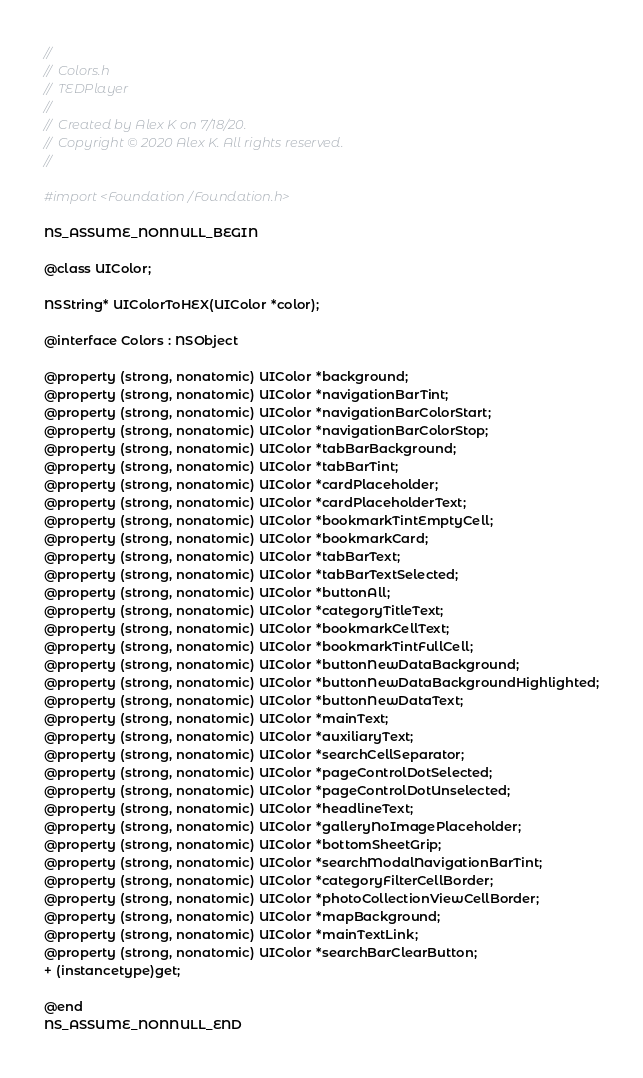Convert code to text. <code><loc_0><loc_0><loc_500><loc_500><_C_>//
//  Colors.h
//  TEDPlayer
//
//  Created by Alex K on 7/18/20.
//  Copyright © 2020 Alex K. All rights reserved.
//

#import <Foundation/Foundation.h>

NS_ASSUME_NONNULL_BEGIN

@class UIColor;

NSString* UIColorToHEX(UIColor *color);

@interface Colors : NSObject

@property (strong, nonatomic) UIColor *background;
@property (strong, nonatomic) UIColor *navigationBarTint;
@property (strong, nonatomic) UIColor *navigationBarColorStart;
@property (strong, nonatomic) UIColor *navigationBarColorStop;
@property (strong, nonatomic) UIColor *tabBarBackground;
@property (strong, nonatomic) UIColor *tabBarTint;
@property (strong, nonatomic) UIColor *cardPlaceholder;
@property (strong, nonatomic) UIColor *cardPlaceholderText;
@property (strong, nonatomic) UIColor *bookmarkTintEmptyCell;
@property (strong, nonatomic) UIColor *bookmarkCard;
@property (strong, nonatomic) UIColor *tabBarText;
@property (strong, nonatomic) UIColor *tabBarTextSelected;
@property (strong, nonatomic) UIColor *buttonAll;
@property (strong, nonatomic) UIColor *categoryTitleText;
@property (strong, nonatomic) UIColor *bookmarkCellText;
@property (strong, nonatomic) UIColor *bookmarkTintFullCell;
@property (strong, nonatomic) UIColor *buttonNewDataBackground;
@property (strong, nonatomic) UIColor *buttonNewDataBackgroundHighlighted;
@property (strong, nonatomic) UIColor *buttonNewDataText;
@property (strong, nonatomic) UIColor *mainText;
@property (strong, nonatomic) UIColor *auxiliaryText;
@property (strong, nonatomic) UIColor *searchCellSeparator;
@property (strong, nonatomic) UIColor *pageControlDotSelected;
@property (strong, nonatomic) UIColor *pageControlDotUnselected;
@property (strong, nonatomic) UIColor *headlineText;
@property (strong, nonatomic) UIColor *galleryNoImagePlaceholder;
@property (strong, nonatomic) UIColor *bottomSheetGrip;
@property (strong, nonatomic) UIColor *searchModalNavigationBarTint;
@property (strong, nonatomic) UIColor *categoryFilterCellBorder;
@property (strong, nonatomic) UIColor *photoCollectionViewCellBorder;
@property (strong, nonatomic) UIColor *mapBackground;
@property (strong, nonatomic) UIColor *mainTextLink;
@property (strong, nonatomic) UIColor *searchBarClearButton;
+ (instancetype)get;

@end
NS_ASSUME_NONNULL_END
</code> 